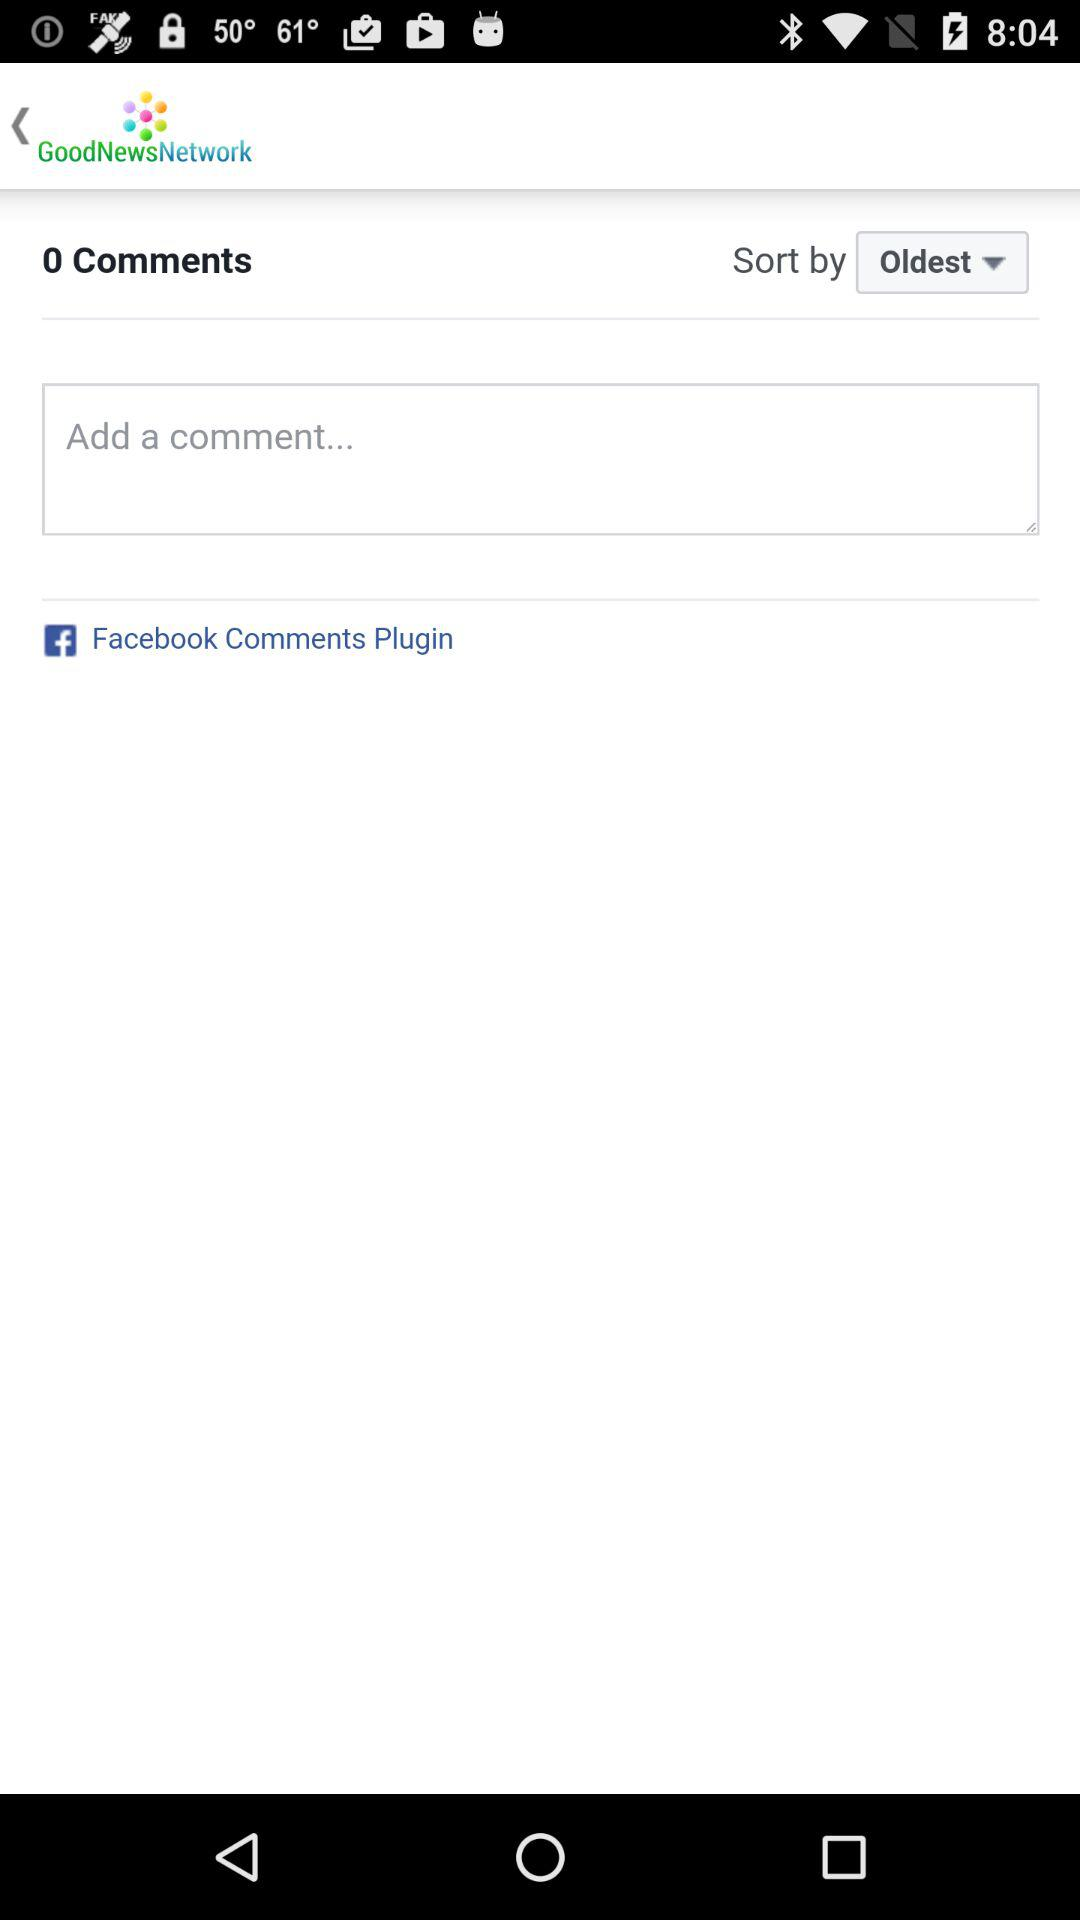What is the name of the application? The name of the application is "GoodNewsNetwork". 